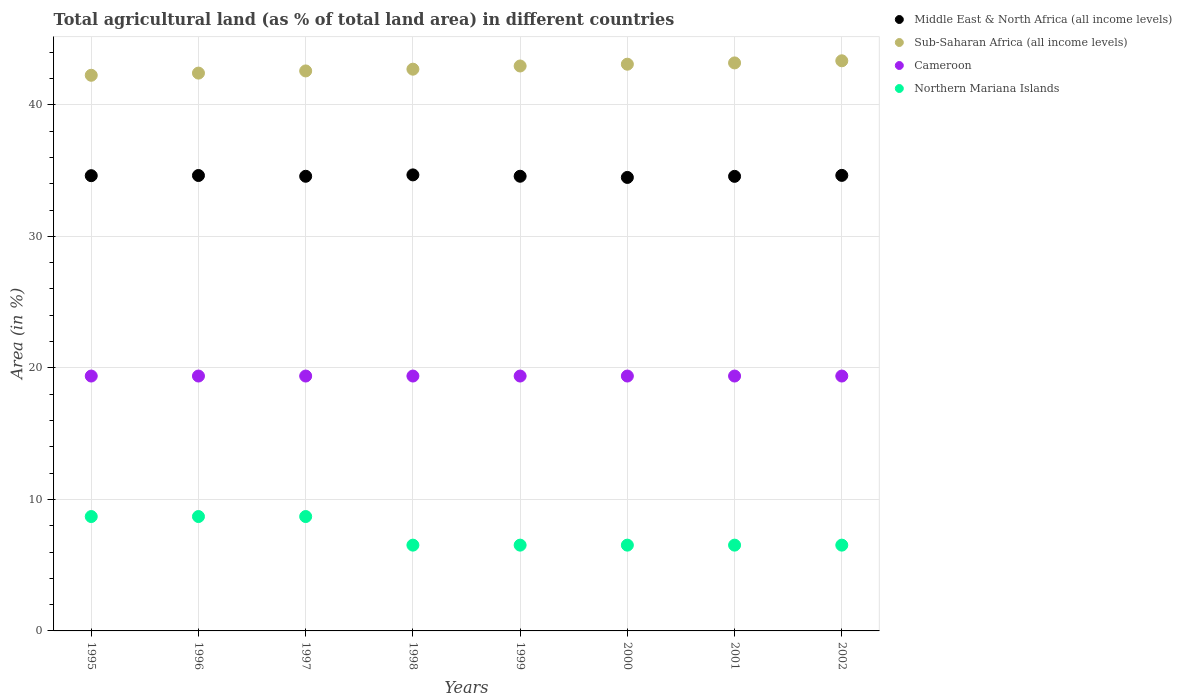How many different coloured dotlines are there?
Provide a succinct answer. 4. Is the number of dotlines equal to the number of legend labels?
Provide a succinct answer. Yes. What is the percentage of agricultural land in Middle East & North Africa (all income levels) in 2001?
Offer a terse response. 34.56. Across all years, what is the maximum percentage of agricultural land in Northern Mariana Islands?
Your answer should be very brief. 8.7. Across all years, what is the minimum percentage of agricultural land in Middle East & North Africa (all income levels)?
Make the answer very short. 34.48. What is the total percentage of agricultural land in Northern Mariana Islands in the graph?
Offer a terse response. 58.7. What is the difference between the percentage of agricultural land in Cameroon in 1997 and that in 2001?
Make the answer very short. 0. What is the difference between the percentage of agricultural land in Cameroon in 2002 and the percentage of agricultural land in Northern Mariana Islands in 1999?
Your answer should be compact. 12.86. What is the average percentage of agricultural land in Sub-Saharan Africa (all income levels) per year?
Give a very brief answer. 42.81. In the year 1998, what is the difference between the percentage of agricultural land in Middle East & North Africa (all income levels) and percentage of agricultural land in Cameroon?
Make the answer very short. 15.29. In how many years, is the percentage of agricultural land in Northern Mariana Islands greater than 6 %?
Keep it short and to the point. 8. What is the ratio of the percentage of agricultural land in Sub-Saharan Africa (all income levels) in 1997 to that in 1998?
Give a very brief answer. 1. In how many years, is the percentage of agricultural land in Sub-Saharan Africa (all income levels) greater than the average percentage of agricultural land in Sub-Saharan Africa (all income levels) taken over all years?
Keep it short and to the point. 4. Does the percentage of agricultural land in Sub-Saharan Africa (all income levels) monotonically increase over the years?
Your response must be concise. Yes. Is the percentage of agricultural land in Northern Mariana Islands strictly less than the percentage of agricultural land in Sub-Saharan Africa (all income levels) over the years?
Offer a very short reply. Yes. How many years are there in the graph?
Make the answer very short. 8. What is the difference between two consecutive major ticks on the Y-axis?
Ensure brevity in your answer.  10. Are the values on the major ticks of Y-axis written in scientific E-notation?
Ensure brevity in your answer.  No. Does the graph contain any zero values?
Ensure brevity in your answer.  No. How many legend labels are there?
Offer a terse response. 4. What is the title of the graph?
Your answer should be very brief. Total agricultural land (as % of total land area) in different countries. Does "Bermuda" appear as one of the legend labels in the graph?
Your answer should be compact. No. What is the label or title of the X-axis?
Your answer should be very brief. Years. What is the label or title of the Y-axis?
Provide a short and direct response. Area (in %). What is the Area (in %) in Middle East & North Africa (all income levels) in 1995?
Offer a terse response. 34.61. What is the Area (in %) of Sub-Saharan Africa (all income levels) in 1995?
Offer a terse response. 42.24. What is the Area (in %) in Cameroon in 1995?
Your response must be concise. 19.38. What is the Area (in %) in Northern Mariana Islands in 1995?
Offer a terse response. 8.7. What is the Area (in %) in Middle East & North Africa (all income levels) in 1996?
Provide a short and direct response. 34.62. What is the Area (in %) in Sub-Saharan Africa (all income levels) in 1996?
Provide a short and direct response. 42.41. What is the Area (in %) of Cameroon in 1996?
Keep it short and to the point. 19.38. What is the Area (in %) of Northern Mariana Islands in 1996?
Keep it short and to the point. 8.7. What is the Area (in %) of Middle East & North Africa (all income levels) in 1997?
Give a very brief answer. 34.56. What is the Area (in %) of Sub-Saharan Africa (all income levels) in 1997?
Provide a short and direct response. 42.57. What is the Area (in %) of Cameroon in 1997?
Your answer should be compact. 19.38. What is the Area (in %) of Northern Mariana Islands in 1997?
Ensure brevity in your answer.  8.7. What is the Area (in %) of Middle East & North Africa (all income levels) in 1998?
Ensure brevity in your answer.  34.67. What is the Area (in %) of Sub-Saharan Africa (all income levels) in 1998?
Your answer should be very brief. 42.71. What is the Area (in %) of Cameroon in 1998?
Offer a terse response. 19.38. What is the Area (in %) of Northern Mariana Islands in 1998?
Your response must be concise. 6.52. What is the Area (in %) in Middle East & North Africa (all income levels) in 1999?
Provide a succinct answer. 34.57. What is the Area (in %) of Sub-Saharan Africa (all income levels) in 1999?
Make the answer very short. 42.95. What is the Area (in %) in Cameroon in 1999?
Your answer should be compact. 19.38. What is the Area (in %) in Northern Mariana Islands in 1999?
Ensure brevity in your answer.  6.52. What is the Area (in %) in Middle East & North Africa (all income levels) in 2000?
Your answer should be compact. 34.48. What is the Area (in %) of Sub-Saharan Africa (all income levels) in 2000?
Provide a short and direct response. 43.09. What is the Area (in %) in Cameroon in 2000?
Give a very brief answer. 19.38. What is the Area (in %) of Northern Mariana Islands in 2000?
Your answer should be compact. 6.52. What is the Area (in %) in Middle East & North Africa (all income levels) in 2001?
Your response must be concise. 34.56. What is the Area (in %) of Sub-Saharan Africa (all income levels) in 2001?
Your answer should be very brief. 43.18. What is the Area (in %) in Cameroon in 2001?
Offer a very short reply. 19.38. What is the Area (in %) in Northern Mariana Islands in 2001?
Offer a terse response. 6.52. What is the Area (in %) in Middle East & North Africa (all income levels) in 2002?
Ensure brevity in your answer.  34.63. What is the Area (in %) of Sub-Saharan Africa (all income levels) in 2002?
Offer a terse response. 43.34. What is the Area (in %) of Cameroon in 2002?
Your answer should be compact. 19.38. What is the Area (in %) of Northern Mariana Islands in 2002?
Your response must be concise. 6.52. Across all years, what is the maximum Area (in %) in Middle East & North Africa (all income levels)?
Provide a succinct answer. 34.67. Across all years, what is the maximum Area (in %) of Sub-Saharan Africa (all income levels)?
Your answer should be very brief. 43.34. Across all years, what is the maximum Area (in %) in Cameroon?
Offer a terse response. 19.38. Across all years, what is the maximum Area (in %) of Northern Mariana Islands?
Give a very brief answer. 8.7. Across all years, what is the minimum Area (in %) in Middle East & North Africa (all income levels)?
Offer a very short reply. 34.48. Across all years, what is the minimum Area (in %) of Sub-Saharan Africa (all income levels)?
Ensure brevity in your answer.  42.24. Across all years, what is the minimum Area (in %) of Cameroon?
Provide a succinct answer. 19.38. Across all years, what is the minimum Area (in %) of Northern Mariana Islands?
Keep it short and to the point. 6.52. What is the total Area (in %) of Middle East & North Africa (all income levels) in the graph?
Your answer should be compact. 276.7. What is the total Area (in %) in Sub-Saharan Africa (all income levels) in the graph?
Keep it short and to the point. 342.5. What is the total Area (in %) of Cameroon in the graph?
Offer a terse response. 155.02. What is the total Area (in %) in Northern Mariana Islands in the graph?
Offer a terse response. 58.7. What is the difference between the Area (in %) of Middle East & North Africa (all income levels) in 1995 and that in 1996?
Offer a terse response. -0.01. What is the difference between the Area (in %) of Sub-Saharan Africa (all income levels) in 1995 and that in 1996?
Offer a very short reply. -0.17. What is the difference between the Area (in %) of Cameroon in 1995 and that in 1996?
Your response must be concise. 0. What is the difference between the Area (in %) of Northern Mariana Islands in 1995 and that in 1996?
Provide a short and direct response. 0. What is the difference between the Area (in %) in Middle East & North Africa (all income levels) in 1995 and that in 1997?
Provide a succinct answer. 0.05. What is the difference between the Area (in %) in Sub-Saharan Africa (all income levels) in 1995 and that in 1997?
Provide a short and direct response. -0.33. What is the difference between the Area (in %) of Middle East & North Africa (all income levels) in 1995 and that in 1998?
Give a very brief answer. -0.06. What is the difference between the Area (in %) of Sub-Saharan Africa (all income levels) in 1995 and that in 1998?
Provide a succinct answer. -0.46. What is the difference between the Area (in %) in Cameroon in 1995 and that in 1998?
Provide a short and direct response. 0. What is the difference between the Area (in %) in Northern Mariana Islands in 1995 and that in 1998?
Offer a terse response. 2.17. What is the difference between the Area (in %) in Middle East & North Africa (all income levels) in 1995 and that in 1999?
Make the answer very short. 0.04. What is the difference between the Area (in %) in Sub-Saharan Africa (all income levels) in 1995 and that in 1999?
Your answer should be compact. -0.71. What is the difference between the Area (in %) of Northern Mariana Islands in 1995 and that in 1999?
Offer a terse response. 2.17. What is the difference between the Area (in %) of Middle East & North Africa (all income levels) in 1995 and that in 2000?
Give a very brief answer. 0.13. What is the difference between the Area (in %) in Sub-Saharan Africa (all income levels) in 1995 and that in 2000?
Keep it short and to the point. -0.84. What is the difference between the Area (in %) in Cameroon in 1995 and that in 2000?
Keep it short and to the point. 0. What is the difference between the Area (in %) of Northern Mariana Islands in 1995 and that in 2000?
Ensure brevity in your answer.  2.17. What is the difference between the Area (in %) of Middle East & North Africa (all income levels) in 1995 and that in 2001?
Offer a very short reply. 0.05. What is the difference between the Area (in %) of Sub-Saharan Africa (all income levels) in 1995 and that in 2001?
Offer a very short reply. -0.94. What is the difference between the Area (in %) in Northern Mariana Islands in 1995 and that in 2001?
Provide a short and direct response. 2.17. What is the difference between the Area (in %) in Middle East & North Africa (all income levels) in 1995 and that in 2002?
Your answer should be compact. -0.02. What is the difference between the Area (in %) of Sub-Saharan Africa (all income levels) in 1995 and that in 2002?
Your answer should be very brief. -1.1. What is the difference between the Area (in %) in Cameroon in 1995 and that in 2002?
Offer a terse response. 0. What is the difference between the Area (in %) in Northern Mariana Islands in 1995 and that in 2002?
Offer a very short reply. 2.17. What is the difference between the Area (in %) in Middle East & North Africa (all income levels) in 1996 and that in 1997?
Your answer should be very brief. 0.06. What is the difference between the Area (in %) of Sub-Saharan Africa (all income levels) in 1996 and that in 1997?
Your answer should be very brief. -0.17. What is the difference between the Area (in %) in Middle East & North Africa (all income levels) in 1996 and that in 1998?
Offer a terse response. -0.05. What is the difference between the Area (in %) of Sub-Saharan Africa (all income levels) in 1996 and that in 1998?
Offer a terse response. -0.3. What is the difference between the Area (in %) of Northern Mariana Islands in 1996 and that in 1998?
Your answer should be very brief. 2.17. What is the difference between the Area (in %) of Middle East & North Africa (all income levels) in 1996 and that in 1999?
Provide a short and direct response. 0.06. What is the difference between the Area (in %) of Sub-Saharan Africa (all income levels) in 1996 and that in 1999?
Ensure brevity in your answer.  -0.54. What is the difference between the Area (in %) in Cameroon in 1996 and that in 1999?
Give a very brief answer. 0. What is the difference between the Area (in %) in Northern Mariana Islands in 1996 and that in 1999?
Offer a terse response. 2.17. What is the difference between the Area (in %) of Middle East & North Africa (all income levels) in 1996 and that in 2000?
Your answer should be compact. 0.15. What is the difference between the Area (in %) in Sub-Saharan Africa (all income levels) in 1996 and that in 2000?
Keep it short and to the point. -0.68. What is the difference between the Area (in %) in Cameroon in 1996 and that in 2000?
Your answer should be very brief. 0. What is the difference between the Area (in %) of Northern Mariana Islands in 1996 and that in 2000?
Your response must be concise. 2.17. What is the difference between the Area (in %) in Middle East & North Africa (all income levels) in 1996 and that in 2001?
Offer a terse response. 0.06. What is the difference between the Area (in %) of Sub-Saharan Africa (all income levels) in 1996 and that in 2001?
Your answer should be compact. -0.77. What is the difference between the Area (in %) in Northern Mariana Islands in 1996 and that in 2001?
Ensure brevity in your answer.  2.17. What is the difference between the Area (in %) in Middle East & North Africa (all income levels) in 1996 and that in 2002?
Provide a short and direct response. -0.01. What is the difference between the Area (in %) in Sub-Saharan Africa (all income levels) in 1996 and that in 2002?
Provide a short and direct response. -0.94. What is the difference between the Area (in %) in Northern Mariana Islands in 1996 and that in 2002?
Your answer should be compact. 2.17. What is the difference between the Area (in %) in Middle East & North Africa (all income levels) in 1997 and that in 1998?
Offer a terse response. -0.11. What is the difference between the Area (in %) of Sub-Saharan Africa (all income levels) in 1997 and that in 1998?
Your answer should be very brief. -0.13. What is the difference between the Area (in %) in Cameroon in 1997 and that in 1998?
Provide a short and direct response. 0. What is the difference between the Area (in %) in Northern Mariana Islands in 1997 and that in 1998?
Your answer should be compact. 2.17. What is the difference between the Area (in %) of Middle East & North Africa (all income levels) in 1997 and that in 1999?
Make the answer very short. -0. What is the difference between the Area (in %) in Sub-Saharan Africa (all income levels) in 1997 and that in 1999?
Offer a very short reply. -0.37. What is the difference between the Area (in %) of Cameroon in 1997 and that in 1999?
Ensure brevity in your answer.  0. What is the difference between the Area (in %) in Northern Mariana Islands in 1997 and that in 1999?
Your answer should be compact. 2.17. What is the difference between the Area (in %) of Middle East & North Africa (all income levels) in 1997 and that in 2000?
Give a very brief answer. 0.09. What is the difference between the Area (in %) of Sub-Saharan Africa (all income levels) in 1997 and that in 2000?
Offer a very short reply. -0.51. What is the difference between the Area (in %) in Cameroon in 1997 and that in 2000?
Give a very brief answer. 0. What is the difference between the Area (in %) of Northern Mariana Islands in 1997 and that in 2000?
Ensure brevity in your answer.  2.17. What is the difference between the Area (in %) in Middle East & North Africa (all income levels) in 1997 and that in 2001?
Ensure brevity in your answer.  0.01. What is the difference between the Area (in %) of Sub-Saharan Africa (all income levels) in 1997 and that in 2001?
Offer a terse response. -0.61. What is the difference between the Area (in %) of Cameroon in 1997 and that in 2001?
Make the answer very short. 0. What is the difference between the Area (in %) in Northern Mariana Islands in 1997 and that in 2001?
Provide a succinct answer. 2.17. What is the difference between the Area (in %) of Middle East & North Africa (all income levels) in 1997 and that in 2002?
Provide a short and direct response. -0.07. What is the difference between the Area (in %) in Sub-Saharan Africa (all income levels) in 1997 and that in 2002?
Provide a short and direct response. -0.77. What is the difference between the Area (in %) of Cameroon in 1997 and that in 2002?
Provide a succinct answer. 0. What is the difference between the Area (in %) in Northern Mariana Islands in 1997 and that in 2002?
Offer a very short reply. 2.17. What is the difference between the Area (in %) in Middle East & North Africa (all income levels) in 1998 and that in 1999?
Offer a terse response. 0.1. What is the difference between the Area (in %) in Sub-Saharan Africa (all income levels) in 1998 and that in 1999?
Your answer should be very brief. -0.24. What is the difference between the Area (in %) of Northern Mariana Islands in 1998 and that in 1999?
Provide a short and direct response. 0. What is the difference between the Area (in %) of Middle East & North Africa (all income levels) in 1998 and that in 2000?
Your answer should be very brief. 0.19. What is the difference between the Area (in %) of Sub-Saharan Africa (all income levels) in 1998 and that in 2000?
Make the answer very short. -0.38. What is the difference between the Area (in %) of Middle East & North Africa (all income levels) in 1998 and that in 2001?
Offer a very short reply. 0.11. What is the difference between the Area (in %) of Sub-Saharan Africa (all income levels) in 1998 and that in 2001?
Your answer should be compact. -0.48. What is the difference between the Area (in %) of Cameroon in 1998 and that in 2001?
Keep it short and to the point. 0. What is the difference between the Area (in %) in Northern Mariana Islands in 1998 and that in 2001?
Ensure brevity in your answer.  0. What is the difference between the Area (in %) of Middle East & North Africa (all income levels) in 1998 and that in 2002?
Offer a terse response. 0.04. What is the difference between the Area (in %) of Sub-Saharan Africa (all income levels) in 1998 and that in 2002?
Keep it short and to the point. -0.64. What is the difference between the Area (in %) in Cameroon in 1998 and that in 2002?
Provide a succinct answer. 0. What is the difference between the Area (in %) in Middle East & North Africa (all income levels) in 1999 and that in 2000?
Provide a succinct answer. 0.09. What is the difference between the Area (in %) in Sub-Saharan Africa (all income levels) in 1999 and that in 2000?
Your response must be concise. -0.14. What is the difference between the Area (in %) in Northern Mariana Islands in 1999 and that in 2000?
Give a very brief answer. 0. What is the difference between the Area (in %) of Middle East & North Africa (all income levels) in 1999 and that in 2001?
Give a very brief answer. 0.01. What is the difference between the Area (in %) in Sub-Saharan Africa (all income levels) in 1999 and that in 2001?
Make the answer very short. -0.23. What is the difference between the Area (in %) in Middle East & North Africa (all income levels) in 1999 and that in 2002?
Make the answer very short. -0.07. What is the difference between the Area (in %) in Sub-Saharan Africa (all income levels) in 1999 and that in 2002?
Offer a terse response. -0.4. What is the difference between the Area (in %) of Middle East & North Africa (all income levels) in 2000 and that in 2001?
Provide a short and direct response. -0.08. What is the difference between the Area (in %) in Sub-Saharan Africa (all income levels) in 2000 and that in 2001?
Keep it short and to the point. -0.1. What is the difference between the Area (in %) of Northern Mariana Islands in 2000 and that in 2001?
Your answer should be compact. 0. What is the difference between the Area (in %) of Middle East & North Africa (all income levels) in 2000 and that in 2002?
Your answer should be compact. -0.16. What is the difference between the Area (in %) of Sub-Saharan Africa (all income levels) in 2000 and that in 2002?
Make the answer very short. -0.26. What is the difference between the Area (in %) in Northern Mariana Islands in 2000 and that in 2002?
Your response must be concise. 0. What is the difference between the Area (in %) in Middle East & North Africa (all income levels) in 2001 and that in 2002?
Keep it short and to the point. -0.07. What is the difference between the Area (in %) of Sub-Saharan Africa (all income levels) in 2001 and that in 2002?
Provide a succinct answer. -0.16. What is the difference between the Area (in %) of Northern Mariana Islands in 2001 and that in 2002?
Offer a terse response. 0. What is the difference between the Area (in %) of Middle East & North Africa (all income levels) in 1995 and the Area (in %) of Sub-Saharan Africa (all income levels) in 1996?
Your answer should be very brief. -7.8. What is the difference between the Area (in %) of Middle East & North Africa (all income levels) in 1995 and the Area (in %) of Cameroon in 1996?
Your answer should be very brief. 15.23. What is the difference between the Area (in %) of Middle East & North Africa (all income levels) in 1995 and the Area (in %) of Northern Mariana Islands in 1996?
Give a very brief answer. 25.91. What is the difference between the Area (in %) in Sub-Saharan Africa (all income levels) in 1995 and the Area (in %) in Cameroon in 1996?
Provide a succinct answer. 22.87. What is the difference between the Area (in %) in Sub-Saharan Africa (all income levels) in 1995 and the Area (in %) in Northern Mariana Islands in 1996?
Provide a succinct answer. 33.55. What is the difference between the Area (in %) of Cameroon in 1995 and the Area (in %) of Northern Mariana Islands in 1996?
Make the answer very short. 10.68. What is the difference between the Area (in %) in Middle East & North Africa (all income levels) in 1995 and the Area (in %) in Sub-Saharan Africa (all income levels) in 1997?
Provide a short and direct response. -7.96. What is the difference between the Area (in %) in Middle East & North Africa (all income levels) in 1995 and the Area (in %) in Cameroon in 1997?
Make the answer very short. 15.23. What is the difference between the Area (in %) in Middle East & North Africa (all income levels) in 1995 and the Area (in %) in Northern Mariana Islands in 1997?
Offer a very short reply. 25.91. What is the difference between the Area (in %) of Sub-Saharan Africa (all income levels) in 1995 and the Area (in %) of Cameroon in 1997?
Ensure brevity in your answer.  22.87. What is the difference between the Area (in %) in Sub-Saharan Africa (all income levels) in 1995 and the Area (in %) in Northern Mariana Islands in 1997?
Your answer should be compact. 33.55. What is the difference between the Area (in %) of Cameroon in 1995 and the Area (in %) of Northern Mariana Islands in 1997?
Give a very brief answer. 10.68. What is the difference between the Area (in %) in Middle East & North Africa (all income levels) in 1995 and the Area (in %) in Sub-Saharan Africa (all income levels) in 1998?
Your answer should be very brief. -8.1. What is the difference between the Area (in %) of Middle East & North Africa (all income levels) in 1995 and the Area (in %) of Cameroon in 1998?
Keep it short and to the point. 15.23. What is the difference between the Area (in %) in Middle East & North Africa (all income levels) in 1995 and the Area (in %) in Northern Mariana Islands in 1998?
Make the answer very short. 28.09. What is the difference between the Area (in %) in Sub-Saharan Africa (all income levels) in 1995 and the Area (in %) in Cameroon in 1998?
Make the answer very short. 22.87. What is the difference between the Area (in %) in Sub-Saharan Africa (all income levels) in 1995 and the Area (in %) in Northern Mariana Islands in 1998?
Ensure brevity in your answer.  35.72. What is the difference between the Area (in %) in Cameroon in 1995 and the Area (in %) in Northern Mariana Islands in 1998?
Offer a terse response. 12.86. What is the difference between the Area (in %) in Middle East & North Africa (all income levels) in 1995 and the Area (in %) in Sub-Saharan Africa (all income levels) in 1999?
Ensure brevity in your answer.  -8.34. What is the difference between the Area (in %) of Middle East & North Africa (all income levels) in 1995 and the Area (in %) of Cameroon in 1999?
Offer a terse response. 15.23. What is the difference between the Area (in %) in Middle East & North Africa (all income levels) in 1995 and the Area (in %) in Northern Mariana Islands in 1999?
Keep it short and to the point. 28.09. What is the difference between the Area (in %) of Sub-Saharan Africa (all income levels) in 1995 and the Area (in %) of Cameroon in 1999?
Offer a terse response. 22.87. What is the difference between the Area (in %) in Sub-Saharan Africa (all income levels) in 1995 and the Area (in %) in Northern Mariana Islands in 1999?
Provide a short and direct response. 35.72. What is the difference between the Area (in %) in Cameroon in 1995 and the Area (in %) in Northern Mariana Islands in 1999?
Give a very brief answer. 12.86. What is the difference between the Area (in %) in Middle East & North Africa (all income levels) in 1995 and the Area (in %) in Sub-Saharan Africa (all income levels) in 2000?
Offer a very short reply. -8.48. What is the difference between the Area (in %) of Middle East & North Africa (all income levels) in 1995 and the Area (in %) of Cameroon in 2000?
Give a very brief answer. 15.23. What is the difference between the Area (in %) in Middle East & North Africa (all income levels) in 1995 and the Area (in %) in Northern Mariana Islands in 2000?
Offer a very short reply. 28.09. What is the difference between the Area (in %) in Sub-Saharan Africa (all income levels) in 1995 and the Area (in %) in Cameroon in 2000?
Your answer should be compact. 22.87. What is the difference between the Area (in %) of Sub-Saharan Africa (all income levels) in 1995 and the Area (in %) of Northern Mariana Islands in 2000?
Give a very brief answer. 35.72. What is the difference between the Area (in %) of Cameroon in 1995 and the Area (in %) of Northern Mariana Islands in 2000?
Your answer should be very brief. 12.86. What is the difference between the Area (in %) of Middle East & North Africa (all income levels) in 1995 and the Area (in %) of Sub-Saharan Africa (all income levels) in 2001?
Provide a succinct answer. -8.57. What is the difference between the Area (in %) in Middle East & North Africa (all income levels) in 1995 and the Area (in %) in Cameroon in 2001?
Offer a very short reply. 15.23. What is the difference between the Area (in %) of Middle East & North Africa (all income levels) in 1995 and the Area (in %) of Northern Mariana Islands in 2001?
Your response must be concise. 28.09. What is the difference between the Area (in %) of Sub-Saharan Africa (all income levels) in 1995 and the Area (in %) of Cameroon in 2001?
Keep it short and to the point. 22.87. What is the difference between the Area (in %) in Sub-Saharan Africa (all income levels) in 1995 and the Area (in %) in Northern Mariana Islands in 2001?
Your answer should be compact. 35.72. What is the difference between the Area (in %) in Cameroon in 1995 and the Area (in %) in Northern Mariana Islands in 2001?
Offer a terse response. 12.86. What is the difference between the Area (in %) of Middle East & North Africa (all income levels) in 1995 and the Area (in %) of Sub-Saharan Africa (all income levels) in 2002?
Your answer should be compact. -8.73. What is the difference between the Area (in %) of Middle East & North Africa (all income levels) in 1995 and the Area (in %) of Cameroon in 2002?
Offer a terse response. 15.23. What is the difference between the Area (in %) in Middle East & North Africa (all income levels) in 1995 and the Area (in %) in Northern Mariana Islands in 2002?
Ensure brevity in your answer.  28.09. What is the difference between the Area (in %) in Sub-Saharan Africa (all income levels) in 1995 and the Area (in %) in Cameroon in 2002?
Your response must be concise. 22.87. What is the difference between the Area (in %) in Sub-Saharan Africa (all income levels) in 1995 and the Area (in %) in Northern Mariana Islands in 2002?
Make the answer very short. 35.72. What is the difference between the Area (in %) of Cameroon in 1995 and the Area (in %) of Northern Mariana Islands in 2002?
Make the answer very short. 12.86. What is the difference between the Area (in %) in Middle East & North Africa (all income levels) in 1996 and the Area (in %) in Sub-Saharan Africa (all income levels) in 1997?
Give a very brief answer. -7.95. What is the difference between the Area (in %) in Middle East & North Africa (all income levels) in 1996 and the Area (in %) in Cameroon in 1997?
Make the answer very short. 15.25. What is the difference between the Area (in %) of Middle East & North Africa (all income levels) in 1996 and the Area (in %) of Northern Mariana Islands in 1997?
Your answer should be compact. 25.93. What is the difference between the Area (in %) in Sub-Saharan Africa (all income levels) in 1996 and the Area (in %) in Cameroon in 1997?
Your answer should be very brief. 23.03. What is the difference between the Area (in %) of Sub-Saharan Africa (all income levels) in 1996 and the Area (in %) of Northern Mariana Islands in 1997?
Your answer should be very brief. 33.71. What is the difference between the Area (in %) of Cameroon in 1996 and the Area (in %) of Northern Mariana Islands in 1997?
Offer a very short reply. 10.68. What is the difference between the Area (in %) in Middle East & North Africa (all income levels) in 1996 and the Area (in %) in Sub-Saharan Africa (all income levels) in 1998?
Offer a very short reply. -8.08. What is the difference between the Area (in %) of Middle East & North Africa (all income levels) in 1996 and the Area (in %) of Cameroon in 1998?
Offer a terse response. 15.25. What is the difference between the Area (in %) of Middle East & North Africa (all income levels) in 1996 and the Area (in %) of Northern Mariana Islands in 1998?
Provide a short and direct response. 28.1. What is the difference between the Area (in %) of Sub-Saharan Africa (all income levels) in 1996 and the Area (in %) of Cameroon in 1998?
Offer a terse response. 23.03. What is the difference between the Area (in %) of Sub-Saharan Africa (all income levels) in 1996 and the Area (in %) of Northern Mariana Islands in 1998?
Offer a terse response. 35.89. What is the difference between the Area (in %) in Cameroon in 1996 and the Area (in %) in Northern Mariana Islands in 1998?
Make the answer very short. 12.86. What is the difference between the Area (in %) in Middle East & North Africa (all income levels) in 1996 and the Area (in %) in Sub-Saharan Africa (all income levels) in 1999?
Give a very brief answer. -8.33. What is the difference between the Area (in %) in Middle East & North Africa (all income levels) in 1996 and the Area (in %) in Cameroon in 1999?
Ensure brevity in your answer.  15.25. What is the difference between the Area (in %) in Middle East & North Africa (all income levels) in 1996 and the Area (in %) in Northern Mariana Islands in 1999?
Make the answer very short. 28.1. What is the difference between the Area (in %) in Sub-Saharan Africa (all income levels) in 1996 and the Area (in %) in Cameroon in 1999?
Ensure brevity in your answer.  23.03. What is the difference between the Area (in %) in Sub-Saharan Africa (all income levels) in 1996 and the Area (in %) in Northern Mariana Islands in 1999?
Ensure brevity in your answer.  35.89. What is the difference between the Area (in %) of Cameroon in 1996 and the Area (in %) of Northern Mariana Islands in 1999?
Make the answer very short. 12.86. What is the difference between the Area (in %) in Middle East & North Africa (all income levels) in 1996 and the Area (in %) in Sub-Saharan Africa (all income levels) in 2000?
Provide a succinct answer. -8.46. What is the difference between the Area (in %) of Middle East & North Africa (all income levels) in 1996 and the Area (in %) of Cameroon in 2000?
Offer a terse response. 15.25. What is the difference between the Area (in %) of Middle East & North Africa (all income levels) in 1996 and the Area (in %) of Northern Mariana Islands in 2000?
Provide a succinct answer. 28.1. What is the difference between the Area (in %) in Sub-Saharan Africa (all income levels) in 1996 and the Area (in %) in Cameroon in 2000?
Ensure brevity in your answer.  23.03. What is the difference between the Area (in %) in Sub-Saharan Africa (all income levels) in 1996 and the Area (in %) in Northern Mariana Islands in 2000?
Your answer should be compact. 35.89. What is the difference between the Area (in %) of Cameroon in 1996 and the Area (in %) of Northern Mariana Islands in 2000?
Provide a succinct answer. 12.86. What is the difference between the Area (in %) of Middle East & North Africa (all income levels) in 1996 and the Area (in %) of Sub-Saharan Africa (all income levels) in 2001?
Your response must be concise. -8.56. What is the difference between the Area (in %) of Middle East & North Africa (all income levels) in 1996 and the Area (in %) of Cameroon in 2001?
Offer a terse response. 15.25. What is the difference between the Area (in %) of Middle East & North Africa (all income levels) in 1996 and the Area (in %) of Northern Mariana Islands in 2001?
Make the answer very short. 28.1. What is the difference between the Area (in %) in Sub-Saharan Africa (all income levels) in 1996 and the Area (in %) in Cameroon in 2001?
Provide a succinct answer. 23.03. What is the difference between the Area (in %) in Sub-Saharan Africa (all income levels) in 1996 and the Area (in %) in Northern Mariana Islands in 2001?
Ensure brevity in your answer.  35.89. What is the difference between the Area (in %) in Cameroon in 1996 and the Area (in %) in Northern Mariana Islands in 2001?
Give a very brief answer. 12.86. What is the difference between the Area (in %) in Middle East & North Africa (all income levels) in 1996 and the Area (in %) in Sub-Saharan Africa (all income levels) in 2002?
Your answer should be very brief. -8.72. What is the difference between the Area (in %) in Middle East & North Africa (all income levels) in 1996 and the Area (in %) in Cameroon in 2002?
Give a very brief answer. 15.25. What is the difference between the Area (in %) of Middle East & North Africa (all income levels) in 1996 and the Area (in %) of Northern Mariana Islands in 2002?
Offer a very short reply. 28.1. What is the difference between the Area (in %) of Sub-Saharan Africa (all income levels) in 1996 and the Area (in %) of Cameroon in 2002?
Offer a very short reply. 23.03. What is the difference between the Area (in %) in Sub-Saharan Africa (all income levels) in 1996 and the Area (in %) in Northern Mariana Islands in 2002?
Make the answer very short. 35.89. What is the difference between the Area (in %) of Cameroon in 1996 and the Area (in %) of Northern Mariana Islands in 2002?
Keep it short and to the point. 12.86. What is the difference between the Area (in %) of Middle East & North Africa (all income levels) in 1997 and the Area (in %) of Sub-Saharan Africa (all income levels) in 1998?
Offer a terse response. -8.14. What is the difference between the Area (in %) in Middle East & North Africa (all income levels) in 1997 and the Area (in %) in Cameroon in 1998?
Your answer should be very brief. 15.19. What is the difference between the Area (in %) in Middle East & North Africa (all income levels) in 1997 and the Area (in %) in Northern Mariana Islands in 1998?
Your response must be concise. 28.04. What is the difference between the Area (in %) of Sub-Saharan Africa (all income levels) in 1997 and the Area (in %) of Cameroon in 1998?
Provide a succinct answer. 23.2. What is the difference between the Area (in %) in Sub-Saharan Africa (all income levels) in 1997 and the Area (in %) in Northern Mariana Islands in 1998?
Offer a terse response. 36.05. What is the difference between the Area (in %) in Cameroon in 1997 and the Area (in %) in Northern Mariana Islands in 1998?
Make the answer very short. 12.86. What is the difference between the Area (in %) of Middle East & North Africa (all income levels) in 1997 and the Area (in %) of Sub-Saharan Africa (all income levels) in 1999?
Your response must be concise. -8.38. What is the difference between the Area (in %) in Middle East & North Africa (all income levels) in 1997 and the Area (in %) in Cameroon in 1999?
Your response must be concise. 15.19. What is the difference between the Area (in %) of Middle East & North Africa (all income levels) in 1997 and the Area (in %) of Northern Mariana Islands in 1999?
Your response must be concise. 28.04. What is the difference between the Area (in %) in Sub-Saharan Africa (all income levels) in 1997 and the Area (in %) in Cameroon in 1999?
Provide a short and direct response. 23.2. What is the difference between the Area (in %) in Sub-Saharan Africa (all income levels) in 1997 and the Area (in %) in Northern Mariana Islands in 1999?
Offer a very short reply. 36.05. What is the difference between the Area (in %) in Cameroon in 1997 and the Area (in %) in Northern Mariana Islands in 1999?
Give a very brief answer. 12.86. What is the difference between the Area (in %) of Middle East & North Africa (all income levels) in 1997 and the Area (in %) of Sub-Saharan Africa (all income levels) in 2000?
Ensure brevity in your answer.  -8.52. What is the difference between the Area (in %) of Middle East & North Africa (all income levels) in 1997 and the Area (in %) of Cameroon in 2000?
Provide a succinct answer. 15.19. What is the difference between the Area (in %) in Middle East & North Africa (all income levels) in 1997 and the Area (in %) in Northern Mariana Islands in 2000?
Offer a very short reply. 28.04. What is the difference between the Area (in %) of Sub-Saharan Africa (all income levels) in 1997 and the Area (in %) of Cameroon in 2000?
Keep it short and to the point. 23.2. What is the difference between the Area (in %) in Sub-Saharan Africa (all income levels) in 1997 and the Area (in %) in Northern Mariana Islands in 2000?
Provide a succinct answer. 36.05. What is the difference between the Area (in %) of Cameroon in 1997 and the Area (in %) of Northern Mariana Islands in 2000?
Your response must be concise. 12.86. What is the difference between the Area (in %) in Middle East & North Africa (all income levels) in 1997 and the Area (in %) in Sub-Saharan Africa (all income levels) in 2001?
Provide a short and direct response. -8.62. What is the difference between the Area (in %) in Middle East & North Africa (all income levels) in 1997 and the Area (in %) in Cameroon in 2001?
Provide a succinct answer. 15.19. What is the difference between the Area (in %) in Middle East & North Africa (all income levels) in 1997 and the Area (in %) in Northern Mariana Islands in 2001?
Ensure brevity in your answer.  28.04. What is the difference between the Area (in %) of Sub-Saharan Africa (all income levels) in 1997 and the Area (in %) of Cameroon in 2001?
Offer a terse response. 23.2. What is the difference between the Area (in %) in Sub-Saharan Africa (all income levels) in 1997 and the Area (in %) in Northern Mariana Islands in 2001?
Offer a terse response. 36.05. What is the difference between the Area (in %) in Cameroon in 1997 and the Area (in %) in Northern Mariana Islands in 2001?
Offer a terse response. 12.86. What is the difference between the Area (in %) in Middle East & North Africa (all income levels) in 1997 and the Area (in %) in Sub-Saharan Africa (all income levels) in 2002?
Keep it short and to the point. -8.78. What is the difference between the Area (in %) in Middle East & North Africa (all income levels) in 1997 and the Area (in %) in Cameroon in 2002?
Provide a short and direct response. 15.19. What is the difference between the Area (in %) of Middle East & North Africa (all income levels) in 1997 and the Area (in %) of Northern Mariana Islands in 2002?
Your answer should be compact. 28.04. What is the difference between the Area (in %) of Sub-Saharan Africa (all income levels) in 1997 and the Area (in %) of Cameroon in 2002?
Offer a terse response. 23.2. What is the difference between the Area (in %) in Sub-Saharan Africa (all income levels) in 1997 and the Area (in %) in Northern Mariana Islands in 2002?
Give a very brief answer. 36.05. What is the difference between the Area (in %) in Cameroon in 1997 and the Area (in %) in Northern Mariana Islands in 2002?
Offer a terse response. 12.86. What is the difference between the Area (in %) in Middle East & North Africa (all income levels) in 1998 and the Area (in %) in Sub-Saharan Africa (all income levels) in 1999?
Offer a terse response. -8.28. What is the difference between the Area (in %) of Middle East & North Africa (all income levels) in 1998 and the Area (in %) of Cameroon in 1999?
Keep it short and to the point. 15.29. What is the difference between the Area (in %) of Middle East & North Africa (all income levels) in 1998 and the Area (in %) of Northern Mariana Islands in 1999?
Ensure brevity in your answer.  28.15. What is the difference between the Area (in %) in Sub-Saharan Africa (all income levels) in 1998 and the Area (in %) in Cameroon in 1999?
Offer a very short reply. 23.33. What is the difference between the Area (in %) in Sub-Saharan Africa (all income levels) in 1998 and the Area (in %) in Northern Mariana Islands in 1999?
Your answer should be very brief. 36.19. What is the difference between the Area (in %) of Cameroon in 1998 and the Area (in %) of Northern Mariana Islands in 1999?
Your answer should be compact. 12.86. What is the difference between the Area (in %) of Middle East & North Africa (all income levels) in 1998 and the Area (in %) of Sub-Saharan Africa (all income levels) in 2000?
Keep it short and to the point. -8.42. What is the difference between the Area (in %) in Middle East & North Africa (all income levels) in 1998 and the Area (in %) in Cameroon in 2000?
Give a very brief answer. 15.29. What is the difference between the Area (in %) in Middle East & North Africa (all income levels) in 1998 and the Area (in %) in Northern Mariana Islands in 2000?
Provide a short and direct response. 28.15. What is the difference between the Area (in %) of Sub-Saharan Africa (all income levels) in 1998 and the Area (in %) of Cameroon in 2000?
Provide a succinct answer. 23.33. What is the difference between the Area (in %) of Sub-Saharan Africa (all income levels) in 1998 and the Area (in %) of Northern Mariana Islands in 2000?
Offer a very short reply. 36.19. What is the difference between the Area (in %) of Cameroon in 1998 and the Area (in %) of Northern Mariana Islands in 2000?
Make the answer very short. 12.86. What is the difference between the Area (in %) of Middle East & North Africa (all income levels) in 1998 and the Area (in %) of Sub-Saharan Africa (all income levels) in 2001?
Give a very brief answer. -8.51. What is the difference between the Area (in %) in Middle East & North Africa (all income levels) in 1998 and the Area (in %) in Cameroon in 2001?
Provide a succinct answer. 15.29. What is the difference between the Area (in %) of Middle East & North Africa (all income levels) in 1998 and the Area (in %) of Northern Mariana Islands in 2001?
Your answer should be compact. 28.15. What is the difference between the Area (in %) in Sub-Saharan Africa (all income levels) in 1998 and the Area (in %) in Cameroon in 2001?
Your answer should be compact. 23.33. What is the difference between the Area (in %) in Sub-Saharan Africa (all income levels) in 1998 and the Area (in %) in Northern Mariana Islands in 2001?
Offer a terse response. 36.19. What is the difference between the Area (in %) in Cameroon in 1998 and the Area (in %) in Northern Mariana Islands in 2001?
Ensure brevity in your answer.  12.86. What is the difference between the Area (in %) of Middle East & North Africa (all income levels) in 1998 and the Area (in %) of Sub-Saharan Africa (all income levels) in 2002?
Your response must be concise. -8.67. What is the difference between the Area (in %) of Middle East & North Africa (all income levels) in 1998 and the Area (in %) of Cameroon in 2002?
Your answer should be very brief. 15.29. What is the difference between the Area (in %) of Middle East & North Africa (all income levels) in 1998 and the Area (in %) of Northern Mariana Islands in 2002?
Give a very brief answer. 28.15. What is the difference between the Area (in %) in Sub-Saharan Africa (all income levels) in 1998 and the Area (in %) in Cameroon in 2002?
Your answer should be very brief. 23.33. What is the difference between the Area (in %) in Sub-Saharan Africa (all income levels) in 1998 and the Area (in %) in Northern Mariana Islands in 2002?
Ensure brevity in your answer.  36.19. What is the difference between the Area (in %) in Cameroon in 1998 and the Area (in %) in Northern Mariana Islands in 2002?
Your response must be concise. 12.86. What is the difference between the Area (in %) in Middle East & North Africa (all income levels) in 1999 and the Area (in %) in Sub-Saharan Africa (all income levels) in 2000?
Your answer should be very brief. -8.52. What is the difference between the Area (in %) in Middle East & North Africa (all income levels) in 1999 and the Area (in %) in Cameroon in 2000?
Your answer should be compact. 15.19. What is the difference between the Area (in %) of Middle East & North Africa (all income levels) in 1999 and the Area (in %) of Northern Mariana Islands in 2000?
Offer a very short reply. 28.05. What is the difference between the Area (in %) of Sub-Saharan Africa (all income levels) in 1999 and the Area (in %) of Cameroon in 2000?
Offer a very short reply. 23.57. What is the difference between the Area (in %) of Sub-Saharan Africa (all income levels) in 1999 and the Area (in %) of Northern Mariana Islands in 2000?
Provide a succinct answer. 36.43. What is the difference between the Area (in %) of Cameroon in 1999 and the Area (in %) of Northern Mariana Islands in 2000?
Provide a short and direct response. 12.86. What is the difference between the Area (in %) of Middle East & North Africa (all income levels) in 1999 and the Area (in %) of Sub-Saharan Africa (all income levels) in 2001?
Provide a succinct answer. -8.62. What is the difference between the Area (in %) of Middle East & North Africa (all income levels) in 1999 and the Area (in %) of Cameroon in 2001?
Your answer should be very brief. 15.19. What is the difference between the Area (in %) of Middle East & North Africa (all income levels) in 1999 and the Area (in %) of Northern Mariana Islands in 2001?
Offer a very short reply. 28.05. What is the difference between the Area (in %) of Sub-Saharan Africa (all income levels) in 1999 and the Area (in %) of Cameroon in 2001?
Offer a very short reply. 23.57. What is the difference between the Area (in %) in Sub-Saharan Africa (all income levels) in 1999 and the Area (in %) in Northern Mariana Islands in 2001?
Your answer should be very brief. 36.43. What is the difference between the Area (in %) in Cameroon in 1999 and the Area (in %) in Northern Mariana Islands in 2001?
Give a very brief answer. 12.86. What is the difference between the Area (in %) in Middle East & North Africa (all income levels) in 1999 and the Area (in %) in Sub-Saharan Africa (all income levels) in 2002?
Keep it short and to the point. -8.78. What is the difference between the Area (in %) of Middle East & North Africa (all income levels) in 1999 and the Area (in %) of Cameroon in 2002?
Give a very brief answer. 15.19. What is the difference between the Area (in %) in Middle East & North Africa (all income levels) in 1999 and the Area (in %) in Northern Mariana Islands in 2002?
Keep it short and to the point. 28.05. What is the difference between the Area (in %) of Sub-Saharan Africa (all income levels) in 1999 and the Area (in %) of Cameroon in 2002?
Make the answer very short. 23.57. What is the difference between the Area (in %) in Sub-Saharan Africa (all income levels) in 1999 and the Area (in %) in Northern Mariana Islands in 2002?
Provide a succinct answer. 36.43. What is the difference between the Area (in %) in Cameroon in 1999 and the Area (in %) in Northern Mariana Islands in 2002?
Your answer should be very brief. 12.86. What is the difference between the Area (in %) of Middle East & North Africa (all income levels) in 2000 and the Area (in %) of Sub-Saharan Africa (all income levels) in 2001?
Keep it short and to the point. -8.71. What is the difference between the Area (in %) of Middle East & North Africa (all income levels) in 2000 and the Area (in %) of Cameroon in 2001?
Provide a succinct answer. 15.1. What is the difference between the Area (in %) of Middle East & North Africa (all income levels) in 2000 and the Area (in %) of Northern Mariana Islands in 2001?
Your answer should be compact. 27.96. What is the difference between the Area (in %) in Sub-Saharan Africa (all income levels) in 2000 and the Area (in %) in Cameroon in 2001?
Ensure brevity in your answer.  23.71. What is the difference between the Area (in %) in Sub-Saharan Africa (all income levels) in 2000 and the Area (in %) in Northern Mariana Islands in 2001?
Offer a very short reply. 36.56. What is the difference between the Area (in %) in Cameroon in 2000 and the Area (in %) in Northern Mariana Islands in 2001?
Your response must be concise. 12.86. What is the difference between the Area (in %) in Middle East & North Africa (all income levels) in 2000 and the Area (in %) in Sub-Saharan Africa (all income levels) in 2002?
Keep it short and to the point. -8.87. What is the difference between the Area (in %) of Middle East & North Africa (all income levels) in 2000 and the Area (in %) of Cameroon in 2002?
Your response must be concise. 15.1. What is the difference between the Area (in %) in Middle East & North Africa (all income levels) in 2000 and the Area (in %) in Northern Mariana Islands in 2002?
Offer a terse response. 27.96. What is the difference between the Area (in %) of Sub-Saharan Africa (all income levels) in 2000 and the Area (in %) of Cameroon in 2002?
Provide a short and direct response. 23.71. What is the difference between the Area (in %) of Sub-Saharan Africa (all income levels) in 2000 and the Area (in %) of Northern Mariana Islands in 2002?
Provide a succinct answer. 36.56. What is the difference between the Area (in %) in Cameroon in 2000 and the Area (in %) in Northern Mariana Islands in 2002?
Your response must be concise. 12.86. What is the difference between the Area (in %) of Middle East & North Africa (all income levels) in 2001 and the Area (in %) of Sub-Saharan Africa (all income levels) in 2002?
Your answer should be compact. -8.79. What is the difference between the Area (in %) in Middle East & North Africa (all income levels) in 2001 and the Area (in %) in Cameroon in 2002?
Offer a terse response. 15.18. What is the difference between the Area (in %) in Middle East & North Africa (all income levels) in 2001 and the Area (in %) in Northern Mariana Islands in 2002?
Provide a short and direct response. 28.04. What is the difference between the Area (in %) of Sub-Saharan Africa (all income levels) in 2001 and the Area (in %) of Cameroon in 2002?
Your answer should be compact. 23.81. What is the difference between the Area (in %) in Sub-Saharan Africa (all income levels) in 2001 and the Area (in %) in Northern Mariana Islands in 2002?
Keep it short and to the point. 36.66. What is the difference between the Area (in %) of Cameroon in 2001 and the Area (in %) of Northern Mariana Islands in 2002?
Offer a terse response. 12.86. What is the average Area (in %) of Middle East & North Africa (all income levels) per year?
Provide a short and direct response. 34.59. What is the average Area (in %) in Sub-Saharan Africa (all income levels) per year?
Offer a very short reply. 42.81. What is the average Area (in %) of Cameroon per year?
Make the answer very short. 19.38. What is the average Area (in %) of Northern Mariana Islands per year?
Provide a succinct answer. 7.34. In the year 1995, what is the difference between the Area (in %) in Middle East & North Africa (all income levels) and Area (in %) in Sub-Saharan Africa (all income levels)?
Offer a terse response. -7.63. In the year 1995, what is the difference between the Area (in %) in Middle East & North Africa (all income levels) and Area (in %) in Cameroon?
Provide a succinct answer. 15.23. In the year 1995, what is the difference between the Area (in %) in Middle East & North Africa (all income levels) and Area (in %) in Northern Mariana Islands?
Your answer should be very brief. 25.91. In the year 1995, what is the difference between the Area (in %) of Sub-Saharan Africa (all income levels) and Area (in %) of Cameroon?
Your answer should be very brief. 22.87. In the year 1995, what is the difference between the Area (in %) of Sub-Saharan Africa (all income levels) and Area (in %) of Northern Mariana Islands?
Make the answer very short. 33.55. In the year 1995, what is the difference between the Area (in %) in Cameroon and Area (in %) in Northern Mariana Islands?
Your answer should be very brief. 10.68. In the year 1996, what is the difference between the Area (in %) of Middle East & North Africa (all income levels) and Area (in %) of Sub-Saharan Africa (all income levels)?
Offer a very short reply. -7.79. In the year 1996, what is the difference between the Area (in %) of Middle East & North Africa (all income levels) and Area (in %) of Cameroon?
Make the answer very short. 15.25. In the year 1996, what is the difference between the Area (in %) of Middle East & North Africa (all income levels) and Area (in %) of Northern Mariana Islands?
Offer a very short reply. 25.93. In the year 1996, what is the difference between the Area (in %) of Sub-Saharan Africa (all income levels) and Area (in %) of Cameroon?
Ensure brevity in your answer.  23.03. In the year 1996, what is the difference between the Area (in %) in Sub-Saharan Africa (all income levels) and Area (in %) in Northern Mariana Islands?
Provide a short and direct response. 33.71. In the year 1996, what is the difference between the Area (in %) in Cameroon and Area (in %) in Northern Mariana Islands?
Ensure brevity in your answer.  10.68. In the year 1997, what is the difference between the Area (in %) of Middle East & North Africa (all income levels) and Area (in %) of Sub-Saharan Africa (all income levels)?
Your answer should be very brief. -8.01. In the year 1997, what is the difference between the Area (in %) of Middle East & North Africa (all income levels) and Area (in %) of Cameroon?
Provide a succinct answer. 15.19. In the year 1997, what is the difference between the Area (in %) in Middle East & North Africa (all income levels) and Area (in %) in Northern Mariana Islands?
Keep it short and to the point. 25.87. In the year 1997, what is the difference between the Area (in %) of Sub-Saharan Africa (all income levels) and Area (in %) of Cameroon?
Provide a short and direct response. 23.2. In the year 1997, what is the difference between the Area (in %) of Sub-Saharan Africa (all income levels) and Area (in %) of Northern Mariana Islands?
Provide a short and direct response. 33.88. In the year 1997, what is the difference between the Area (in %) of Cameroon and Area (in %) of Northern Mariana Islands?
Your answer should be very brief. 10.68. In the year 1998, what is the difference between the Area (in %) in Middle East & North Africa (all income levels) and Area (in %) in Sub-Saharan Africa (all income levels)?
Keep it short and to the point. -8.04. In the year 1998, what is the difference between the Area (in %) in Middle East & North Africa (all income levels) and Area (in %) in Cameroon?
Your answer should be compact. 15.29. In the year 1998, what is the difference between the Area (in %) of Middle East & North Africa (all income levels) and Area (in %) of Northern Mariana Islands?
Provide a succinct answer. 28.15. In the year 1998, what is the difference between the Area (in %) in Sub-Saharan Africa (all income levels) and Area (in %) in Cameroon?
Provide a short and direct response. 23.33. In the year 1998, what is the difference between the Area (in %) in Sub-Saharan Africa (all income levels) and Area (in %) in Northern Mariana Islands?
Provide a succinct answer. 36.19. In the year 1998, what is the difference between the Area (in %) in Cameroon and Area (in %) in Northern Mariana Islands?
Offer a very short reply. 12.86. In the year 1999, what is the difference between the Area (in %) of Middle East & North Africa (all income levels) and Area (in %) of Sub-Saharan Africa (all income levels)?
Give a very brief answer. -8.38. In the year 1999, what is the difference between the Area (in %) of Middle East & North Africa (all income levels) and Area (in %) of Cameroon?
Provide a short and direct response. 15.19. In the year 1999, what is the difference between the Area (in %) in Middle East & North Africa (all income levels) and Area (in %) in Northern Mariana Islands?
Ensure brevity in your answer.  28.05. In the year 1999, what is the difference between the Area (in %) in Sub-Saharan Africa (all income levels) and Area (in %) in Cameroon?
Provide a short and direct response. 23.57. In the year 1999, what is the difference between the Area (in %) in Sub-Saharan Africa (all income levels) and Area (in %) in Northern Mariana Islands?
Make the answer very short. 36.43. In the year 1999, what is the difference between the Area (in %) in Cameroon and Area (in %) in Northern Mariana Islands?
Provide a short and direct response. 12.86. In the year 2000, what is the difference between the Area (in %) in Middle East & North Africa (all income levels) and Area (in %) in Sub-Saharan Africa (all income levels)?
Provide a short and direct response. -8.61. In the year 2000, what is the difference between the Area (in %) in Middle East & North Africa (all income levels) and Area (in %) in Cameroon?
Your answer should be very brief. 15.1. In the year 2000, what is the difference between the Area (in %) in Middle East & North Africa (all income levels) and Area (in %) in Northern Mariana Islands?
Provide a short and direct response. 27.96. In the year 2000, what is the difference between the Area (in %) of Sub-Saharan Africa (all income levels) and Area (in %) of Cameroon?
Your answer should be compact. 23.71. In the year 2000, what is the difference between the Area (in %) in Sub-Saharan Africa (all income levels) and Area (in %) in Northern Mariana Islands?
Give a very brief answer. 36.56. In the year 2000, what is the difference between the Area (in %) in Cameroon and Area (in %) in Northern Mariana Islands?
Keep it short and to the point. 12.86. In the year 2001, what is the difference between the Area (in %) of Middle East & North Africa (all income levels) and Area (in %) of Sub-Saharan Africa (all income levels)?
Give a very brief answer. -8.62. In the year 2001, what is the difference between the Area (in %) in Middle East & North Africa (all income levels) and Area (in %) in Cameroon?
Keep it short and to the point. 15.18. In the year 2001, what is the difference between the Area (in %) of Middle East & North Africa (all income levels) and Area (in %) of Northern Mariana Islands?
Offer a terse response. 28.04. In the year 2001, what is the difference between the Area (in %) in Sub-Saharan Africa (all income levels) and Area (in %) in Cameroon?
Give a very brief answer. 23.81. In the year 2001, what is the difference between the Area (in %) of Sub-Saharan Africa (all income levels) and Area (in %) of Northern Mariana Islands?
Make the answer very short. 36.66. In the year 2001, what is the difference between the Area (in %) of Cameroon and Area (in %) of Northern Mariana Islands?
Give a very brief answer. 12.86. In the year 2002, what is the difference between the Area (in %) of Middle East & North Africa (all income levels) and Area (in %) of Sub-Saharan Africa (all income levels)?
Your answer should be very brief. -8.71. In the year 2002, what is the difference between the Area (in %) of Middle East & North Africa (all income levels) and Area (in %) of Cameroon?
Your response must be concise. 15.25. In the year 2002, what is the difference between the Area (in %) of Middle East & North Africa (all income levels) and Area (in %) of Northern Mariana Islands?
Ensure brevity in your answer.  28.11. In the year 2002, what is the difference between the Area (in %) in Sub-Saharan Africa (all income levels) and Area (in %) in Cameroon?
Ensure brevity in your answer.  23.97. In the year 2002, what is the difference between the Area (in %) of Sub-Saharan Africa (all income levels) and Area (in %) of Northern Mariana Islands?
Provide a succinct answer. 36.82. In the year 2002, what is the difference between the Area (in %) in Cameroon and Area (in %) in Northern Mariana Islands?
Make the answer very short. 12.86. What is the ratio of the Area (in %) in Middle East & North Africa (all income levels) in 1995 to that in 1996?
Give a very brief answer. 1. What is the ratio of the Area (in %) of Sub-Saharan Africa (all income levels) in 1995 to that in 1996?
Offer a very short reply. 1. What is the ratio of the Area (in %) in Cameroon in 1995 to that in 1996?
Give a very brief answer. 1. What is the ratio of the Area (in %) of Cameroon in 1995 to that in 1997?
Your answer should be compact. 1. What is the ratio of the Area (in %) of Northern Mariana Islands in 1995 to that in 1998?
Provide a succinct answer. 1.33. What is the ratio of the Area (in %) in Sub-Saharan Africa (all income levels) in 1995 to that in 1999?
Keep it short and to the point. 0.98. What is the ratio of the Area (in %) of Northern Mariana Islands in 1995 to that in 1999?
Provide a short and direct response. 1.33. What is the ratio of the Area (in %) of Sub-Saharan Africa (all income levels) in 1995 to that in 2000?
Keep it short and to the point. 0.98. What is the ratio of the Area (in %) of Cameroon in 1995 to that in 2000?
Ensure brevity in your answer.  1. What is the ratio of the Area (in %) of Middle East & North Africa (all income levels) in 1995 to that in 2001?
Provide a short and direct response. 1. What is the ratio of the Area (in %) in Sub-Saharan Africa (all income levels) in 1995 to that in 2001?
Offer a terse response. 0.98. What is the ratio of the Area (in %) in Northern Mariana Islands in 1995 to that in 2001?
Provide a succinct answer. 1.33. What is the ratio of the Area (in %) in Middle East & North Africa (all income levels) in 1995 to that in 2002?
Keep it short and to the point. 1. What is the ratio of the Area (in %) of Sub-Saharan Africa (all income levels) in 1995 to that in 2002?
Keep it short and to the point. 0.97. What is the ratio of the Area (in %) of Sub-Saharan Africa (all income levels) in 1996 to that in 1997?
Your response must be concise. 1. What is the ratio of the Area (in %) of Cameroon in 1996 to that in 1997?
Offer a very short reply. 1. What is the ratio of the Area (in %) of Sub-Saharan Africa (all income levels) in 1996 to that in 1998?
Keep it short and to the point. 0.99. What is the ratio of the Area (in %) in Cameroon in 1996 to that in 1998?
Your response must be concise. 1. What is the ratio of the Area (in %) of Northern Mariana Islands in 1996 to that in 1998?
Offer a terse response. 1.33. What is the ratio of the Area (in %) of Middle East & North Africa (all income levels) in 1996 to that in 1999?
Ensure brevity in your answer.  1. What is the ratio of the Area (in %) of Sub-Saharan Africa (all income levels) in 1996 to that in 1999?
Provide a succinct answer. 0.99. What is the ratio of the Area (in %) in Cameroon in 1996 to that in 1999?
Offer a very short reply. 1. What is the ratio of the Area (in %) in Northern Mariana Islands in 1996 to that in 1999?
Offer a very short reply. 1.33. What is the ratio of the Area (in %) of Sub-Saharan Africa (all income levels) in 1996 to that in 2000?
Ensure brevity in your answer.  0.98. What is the ratio of the Area (in %) of Middle East & North Africa (all income levels) in 1996 to that in 2001?
Give a very brief answer. 1. What is the ratio of the Area (in %) of Sub-Saharan Africa (all income levels) in 1996 to that in 2001?
Keep it short and to the point. 0.98. What is the ratio of the Area (in %) in Sub-Saharan Africa (all income levels) in 1996 to that in 2002?
Make the answer very short. 0.98. What is the ratio of the Area (in %) of Northern Mariana Islands in 1996 to that in 2002?
Provide a succinct answer. 1.33. What is the ratio of the Area (in %) in Middle East & North Africa (all income levels) in 1997 to that in 1998?
Ensure brevity in your answer.  1. What is the ratio of the Area (in %) of Sub-Saharan Africa (all income levels) in 1997 to that in 1998?
Offer a terse response. 1. What is the ratio of the Area (in %) of Northern Mariana Islands in 1997 to that in 1998?
Provide a succinct answer. 1.33. What is the ratio of the Area (in %) of Cameroon in 1997 to that in 1999?
Ensure brevity in your answer.  1. What is the ratio of the Area (in %) of Northern Mariana Islands in 1997 to that in 2000?
Make the answer very short. 1.33. What is the ratio of the Area (in %) of Sub-Saharan Africa (all income levels) in 1997 to that in 2001?
Provide a succinct answer. 0.99. What is the ratio of the Area (in %) in Cameroon in 1997 to that in 2001?
Provide a short and direct response. 1. What is the ratio of the Area (in %) of Northern Mariana Islands in 1997 to that in 2001?
Give a very brief answer. 1.33. What is the ratio of the Area (in %) in Sub-Saharan Africa (all income levels) in 1997 to that in 2002?
Provide a succinct answer. 0.98. What is the ratio of the Area (in %) in Cameroon in 1997 to that in 2002?
Provide a short and direct response. 1. What is the ratio of the Area (in %) in Northern Mariana Islands in 1997 to that in 2002?
Your response must be concise. 1.33. What is the ratio of the Area (in %) in Middle East & North Africa (all income levels) in 1998 to that in 1999?
Ensure brevity in your answer.  1. What is the ratio of the Area (in %) of Sub-Saharan Africa (all income levels) in 1998 to that in 1999?
Give a very brief answer. 0.99. What is the ratio of the Area (in %) in Cameroon in 1998 to that in 1999?
Offer a very short reply. 1. What is the ratio of the Area (in %) in Middle East & North Africa (all income levels) in 1998 to that in 2000?
Your answer should be very brief. 1.01. What is the ratio of the Area (in %) of Northern Mariana Islands in 1998 to that in 2000?
Ensure brevity in your answer.  1. What is the ratio of the Area (in %) in Middle East & North Africa (all income levels) in 1998 to that in 2001?
Ensure brevity in your answer.  1. What is the ratio of the Area (in %) of Northern Mariana Islands in 1998 to that in 2001?
Provide a succinct answer. 1. What is the ratio of the Area (in %) of Sub-Saharan Africa (all income levels) in 1998 to that in 2002?
Your answer should be compact. 0.99. What is the ratio of the Area (in %) of Cameroon in 1998 to that in 2002?
Provide a short and direct response. 1. What is the ratio of the Area (in %) of Middle East & North Africa (all income levels) in 1999 to that in 2000?
Your answer should be compact. 1. What is the ratio of the Area (in %) in Sub-Saharan Africa (all income levels) in 1999 to that in 2000?
Give a very brief answer. 1. What is the ratio of the Area (in %) in Sub-Saharan Africa (all income levels) in 1999 to that in 2001?
Your answer should be compact. 0.99. What is the ratio of the Area (in %) in Northern Mariana Islands in 1999 to that in 2001?
Ensure brevity in your answer.  1. What is the ratio of the Area (in %) of Sub-Saharan Africa (all income levels) in 1999 to that in 2002?
Provide a short and direct response. 0.99. What is the ratio of the Area (in %) in Cameroon in 1999 to that in 2002?
Offer a very short reply. 1. What is the ratio of the Area (in %) of Northern Mariana Islands in 1999 to that in 2002?
Your answer should be compact. 1. What is the ratio of the Area (in %) of Middle East & North Africa (all income levels) in 2000 to that in 2001?
Your answer should be very brief. 1. What is the ratio of the Area (in %) in Cameroon in 2000 to that in 2001?
Make the answer very short. 1. What is the ratio of the Area (in %) in Northern Mariana Islands in 2000 to that in 2001?
Your answer should be very brief. 1. What is the ratio of the Area (in %) of Middle East & North Africa (all income levels) in 2000 to that in 2002?
Offer a very short reply. 1. What is the ratio of the Area (in %) in Cameroon in 2000 to that in 2002?
Provide a succinct answer. 1. What is the ratio of the Area (in %) in Northern Mariana Islands in 2000 to that in 2002?
Make the answer very short. 1. What is the ratio of the Area (in %) of Middle East & North Africa (all income levels) in 2001 to that in 2002?
Keep it short and to the point. 1. What is the ratio of the Area (in %) in Sub-Saharan Africa (all income levels) in 2001 to that in 2002?
Your answer should be very brief. 1. What is the ratio of the Area (in %) of Cameroon in 2001 to that in 2002?
Keep it short and to the point. 1. What is the difference between the highest and the second highest Area (in %) in Middle East & North Africa (all income levels)?
Keep it short and to the point. 0.04. What is the difference between the highest and the second highest Area (in %) of Sub-Saharan Africa (all income levels)?
Make the answer very short. 0.16. What is the difference between the highest and the second highest Area (in %) of Cameroon?
Make the answer very short. 0. What is the difference between the highest and the second highest Area (in %) of Northern Mariana Islands?
Your response must be concise. 0. What is the difference between the highest and the lowest Area (in %) in Middle East & North Africa (all income levels)?
Offer a terse response. 0.19. What is the difference between the highest and the lowest Area (in %) in Sub-Saharan Africa (all income levels)?
Offer a terse response. 1.1. What is the difference between the highest and the lowest Area (in %) of Northern Mariana Islands?
Offer a terse response. 2.17. 